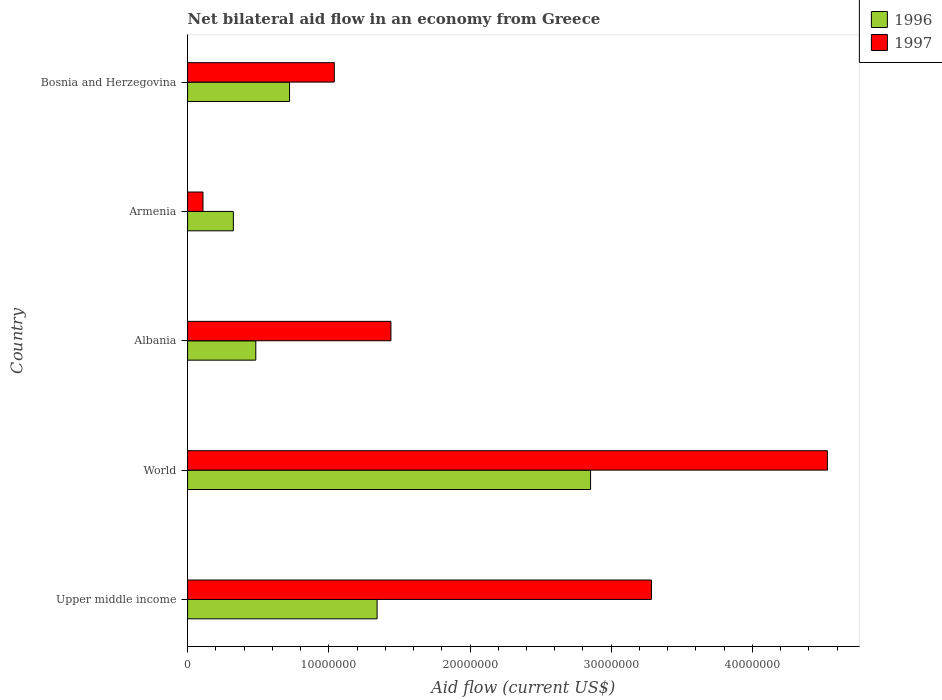Are the number of bars per tick equal to the number of legend labels?
Your response must be concise. Yes. What is the net bilateral aid flow in 1997 in World?
Your answer should be compact. 4.53e+07. Across all countries, what is the maximum net bilateral aid flow in 1997?
Make the answer very short. 4.53e+07. Across all countries, what is the minimum net bilateral aid flow in 1996?
Offer a terse response. 3.24e+06. In which country was the net bilateral aid flow in 1996 maximum?
Offer a terse response. World. In which country was the net bilateral aid flow in 1997 minimum?
Your answer should be compact. Armenia. What is the total net bilateral aid flow in 1997 in the graph?
Provide a short and direct response. 1.04e+08. What is the difference between the net bilateral aid flow in 1997 in Albania and that in Armenia?
Give a very brief answer. 1.33e+07. What is the difference between the net bilateral aid flow in 1997 in Upper middle income and the net bilateral aid flow in 1996 in Bosnia and Herzegovina?
Offer a terse response. 2.56e+07. What is the average net bilateral aid flow in 1997 per country?
Give a very brief answer. 2.08e+07. What is the difference between the net bilateral aid flow in 1996 and net bilateral aid flow in 1997 in Bosnia and Herzegovina?
Your answer should be compact. -3.17e+06. What is the ratio of the net bilateral aid flow in 1996 in Armenia to that in Upper middle income?
Make the answer very short. 0.24. Is the net bilateral aid flow in 1997 in Bosnia and Herzegovina less than that in Upper middle income?
Make the answer very short. Yes. What is the difference between the highest and the second highest net bilateral aid flow in 1997?
Ensure brevity in your answer.  1.25e+07. What is the difference between the highest and the lowest net bilateral aid flow in 1996?
Provide a short and direct response. 2.53e+07. What does the 1st bar from the bottom in Bosnia and Herzegovina represents?
Offer a very short reply. 1996. How many bars are there?
Offer a terse response. 10. Are all the bars in the graph horizontal?
Give a very brief answer. Yes. Are the values on the major ticks of X-axis written in scientific E-notation?
Keep it short and to the point. No. Does the graph contain any zero values?
Your answer should be very brief. No. Does the graph contain grids?
Provide a succinct answer. No. Where does the legend appear in the graph?
Keep it short and to the point. Top right. How are the legend labels stacked?
Your response must be concise. Vertical. What is the title of the graph?
Offer a terse response. Net bilateral aid flow in an economy from Greece. Does "1986" appear as one of the legend labels in the graph?
Make the answer very short. No. What is the Aid flow (current US$) of 1996 in Upper middle income?
Offer a terse response. 1.34e+07. What is the Aid flow (current US$) of 1997 in Upper middle income?
Provide a succinct answer. 3.28e+07. What is the Aid flow (current US$) of 1996 in World?
Provide a short and direct response. 2.85e+07. What is the Aid flow (current US$) of 1997 in World?
Your answer should be very brief. 4.53e+07. What is the Aid flow (current US$) in 1996 in Albania?
Your answer should be very brief. 4.83e+06. What is the Aid flow (current US$) in 1997 in Albania?
Offer a terse response. 1.44e+07. What is the Aid flow (current US$) in 1996 in Armenia?
Give a very brief answer. 3.24e+06. What is the Aid flow (current US$) in 1997 in Armenia?
Make the answer very short. 1.09e+06. What is the Aid flow (current US$) of 1996 in Bosnia and Herzegovina?
Your answer should be very brief. 7.22e+06. What is the Aid flow (current US$) in 1997 in Bosnia and Herzegovina?
Your answer should be compact. 1.04e+07. Across all countries, what is the maximum Aid flow (current US$) of 1996?
Keep it short and to the point. 2.85e+07. Across all countries, what is the maximum Aid flow (current US$) in 1997?
Ensure brevity in your answer.  4.53e+07. Across all countries, what is the minimum Aid flow (current US$) of 1996?
Offer a very short reply. 3.24e+06. Across all countries, what is the minimum Aid flow (current US$) in 1997?
Your answer should be compact. 1.09e+06. What is the total Aid flow (current US$) of 1996 in the graph?
Ensure brevity in your answer.  5.72e+07. What is the total Aid flow (current US$) in 1997 in the graph?
Keep it short and to the point. 1.04e+08. What is the difference between the Aid flow (current US$) of 1996 in Upper middle income and that in World?
Give a very brief answer. -1.51e+07. What is the difference between the Aid flow (current US$) in 1997 in Upper middle income and that in World?
Ensure brevity in your answer.  -1.25e+07. What is the difference between the Aid flow (current US$) in 1996 in Upper middle income and that in Albania?
Provide a short and direct response. 8.59e+06. What is the difference between the Aid flow (current US$) in 1997 in Upper middle income and that in Albania?
Offer a terse response. 1.84e+07. What is the difference between the Aid flow (current US$) in 1996 in Upper middle income and that in Armenia?
Your answer should be compact. 1.02e+07. What is the difference between the Aid flow (current US$) in 1997 in Upper middle income and that in Armenia?
Offer a terse response. 3.18e+07. What is the difference between the Aid flow (current US$) of 1996 in Upper middle income and that in Bosnia and Herzegovina?
Keep it short and to the point. 6.20e+06. What is the difference between the Aid flow (current US$) in 1997 in Upper middle income and that in Bosnia and Herzegovina?
Ensure brevity in your answer.  2.25e+07. What is the difference between the Aid flow (current US$) of 1996 in World and that in Albania?
Give a very brief answer. 2.37e+07. What is the difference between the Aid flow (current US$) of 1997 in World and that in Albania?
Give a very brief answer. 3.09e+07. What is the difference between the Aid flow (current US$) of 1996 in World and that in Armenia?
Your response must be concise. 2.53e+07. What is the difference between the Aid flow (current US$) in 1997 in World and that in Armenia?
Provide a short and direct response. 4.42e+07. What is the difference between the Aid flow (current US$) of 1996 in World and that in Bosnia and Herzegovina?
Make the answer very short. 2.13e+07. What is the difference between the Aid flow (current US$) in 1997 in World and that in Bosnia and Herzegovina?
Provide a short and direct response. 3.49e+07. What is the difference between the Aid flow (current US$) in 1996 in Albania and that in Armenia?
Ensure brevity in your answer.  1.59e+06. What is the difference between the Aid flow (current US$) of 1997 in Albania and that in Armenia?
Your answer should be compact. 1.33e+07. What is the difference between the Aid flow (current US$) in 1996 in Albania and that in Bosnia and Herzegovina?
Ensure brevity in your answer.  -2.39e+06. What is the difference between the Aid flow (current US$) in 1997 in Albania and that in Bosnia and Herzegovina?
Offer a terse response. 4.01e+06. What is the difference between the Aid flow (current US$) of 1996 in Armenia and that in Bosnia and Herzegovina?
Give a very brief answer. -3.98e+06. What is the difference between the Aid flow (current US$) of 1997 in Armenia and that in Bosnia and Herzegovina?
Give a very brief answer. -9.30e+06. What is the difference between the Aid flow (current US$) of 1996 in Upper middle income and the Aid flow (current US$) of 1997 in World?
Provide a succinct answer. -3.19e+07. What is the difference between the Aid flow (current US$) in 1996 in Upper middle income and the Aid flow (current US$) in 1997 in Albania?
Keep it short and to the point. -9.80e+05. What is the difference between the Aid flow (current US$) of 1996 in Upper middle income and the Aid flow (current US$) of 1997 in Armenia?
Your response must be concise. 1.23e+07. What is the difference between the Aid flow (current US$) in 1996 in Upper middle income and the Aid flow (current US$) in 1997 in Bosnia and Herzegovina?
Make the answer very short. 3.03e+06. What is the difference between the Aid flow (current US$) of 1996 in World and the Aid flow (current US$) of 1997 in Albania?
Offer a very short reply. 1.41e+07. What is the difference between the Aid flow (current US$) in 1996 in World and the Aid flow (current US$) in 1997 in Armenia?
Your answer should be compact. 2.74e+07. What is the difference between the Aid flow (current US$) in 1996 in World and the Aid flow (current US$) in 1997 in Bosnia and Herzegovina?
Your answer should be very brief. 1.82e+07. What is the difference between the Aid flow (current US$) of 1996 in Albania and the Aid flow (current US$) of 1997 in Armenia?
Keep it short and to the point. 3.74e+06. What is the difference between the Aid flow (current US$) of 1996 in Albania and the Aid flow (current US$) of 1997 in Bosnia and Herzegovina?
Your answer should be compact. -5.56e+06. What is the difference between the Aid flow (current US$) in 1996 in Armenia and the Aid flow (current US$) in 1997 in Bosnia and Herzegovina?
Give a very brief answer. -7.15e+06. What is the average Aid flow (current US$) of 1996 per country?
Your answer should be compact. 1.14e+07. What is the average Aid flow (current US$) of 1997 per country?
Offer a terse response. 2.08e+07. What is the difference between the Aid flow (current US$) in 1996 and Aid flow (current US$) in 1997 in Upper middle income?
Ensure brevity in your answer.  -1.94e+07. What is the difference between the Aid flow (current US$) in 1996 and Aid flow (current US$) in 1997 in World?
Keep it short and to the point. -1.68e+07. What is the difference between the Aid flow (current US$) in 1996 and Aid flow (current US$) in 1997 in Albania?
Your response must be concise. -9.57e+06. What is the difference between the Aid flow (current US$) in 1996 and Aid flow (current US$) in 1997 in Armenia?
Your answer should be compact. 2.15e+06. What is the difference between the Aid flow (current US$) of 1996 and Aid flow (current US$) of 1997 in Bosnia and Herzegovina?
Give a very brief answer. -3.17e+06. What is the ratio of the Aid flow (current US$) in 1996 in Upper middle income to that in World?
Provide a short and direct response. 0.47. What is the ratio of the Aid flow (current US$) of 1997 in Upper middle income to that in World?
Give a very brief answer. 0.72. What is the ratio of the Aid flow (current US$) in 1996 in Upper middle income to that in Albania?
Offer a very short reply. 2.78. What is the ratio of the Aid flow (current US$) of 1997 in Upper middle income to that in Albania?
Your answer should be very brief. 2.28. What is the ratio of the Aid flow (current US$) in 1996 in Upper middle income to that in Armenia?
Provide a succinct answer. 4.14. What is the ratio of the Aid flow (current US$) of 1997 in Upper middle income to that in Armenia?
Provide a short and direct response. 30.14. What is the ratio of the Aid flow (current US$) of 1996 in Upper middle income to that in Bosnia and Herzegovina?
Provide a short and direct response. 1.86. What is the ratio of the Aid flow (current US$) in 1997 in Upper middle income to that in Bosnia and Herzegovina?
Offer a terse response. 3.16. What is the ratio of the Aid flow (current US$) in 1996 in World to that in Albania?
Ensure brevity in your answer.  5.91. What is the ratio of the Aid flow (current US$) in 1997 in World to that in Albania?
Your answer should be very brief. 3.15. What is the ratio of the Aid flow (current US$) of 1996 in World to that in Armenia?
Your answer should be compact. 8.81. What is the ratio of the Aid flow (current US$) in 1997 in World to that in Armenia?
Your answer should be compact. 41.57. What is the ratio of the Aid flow (current US$) of 1996 in World to that in Bosnia and Herzegovina?
Provide a short and direct response. 3.95. What is the ratio of the Aid flow (current US$) in 1997 in World to that in Bosnia and Herzegovina?
Make the answer very short. 4.36. What is the ratio of the Aid flow (current US$) of 1996 in Albania to that in Armenia?
Keep it short and to the point. 1.49. What is the ratio of the Aid flow (current US$) in 1997 in Albania to that in Armenia?
Make the answer very short. 13.21. What is the ratio of the Aid flow (current US$) in 1996 in Albania to that in Bosnia and Herzegovina?
Provide a succinct answer. 0.67. What is the ratio of the Aid flow (current US$) in 1997 in Albania to that in Bosnia and Herzegovina?
Provide a succinct answer. 1.39. What is the ratio of the Aid flow (current US$) of 1996 in Armenia to that in Bosnia and Herzegovina?
Keep it short and to the point. 0.45. What is the ratio of the Aid flow (current US$) of 1997 in Armenia to that in Bosnia and Herzegovina?
Offer a terse response. 0.1. What is the difference between the highest and the second highest Aid flow (current US$) of 1996?
Offer a terse response. 1.51e+07. What is the difference between the highest and the second highest Aid flow (current US$) of 1997?
Your response must be concise. 1.25e+07. What is the difference between the highest and the lowest Aid flow (current US$) in 1996?
Your answer should be compact. 2.53e+07. What is the difference between the highest and the lowest Aid flow (current US$) in 1997?
Give a very brief answer. 4.42e+07. 